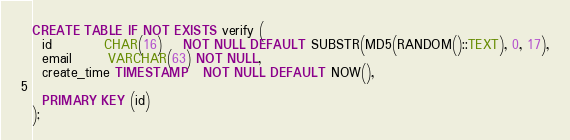<code> <loc_0><loc_0><loc_500><loc_500><_SQL_>CREATE TABLE IF NOT EXISTS verify (
  id          CHAR(16)    NOT NULL DEFAULT SUBSTR(MD5(RANDOM()::TEXT), 0, 17),
  email       VARCHAR(63) NOT NULL,
  create_time TIMESTAMP   NOT NULL DEFAULT NOW(),

  PRIMARY KEY (id)
);
</code> 